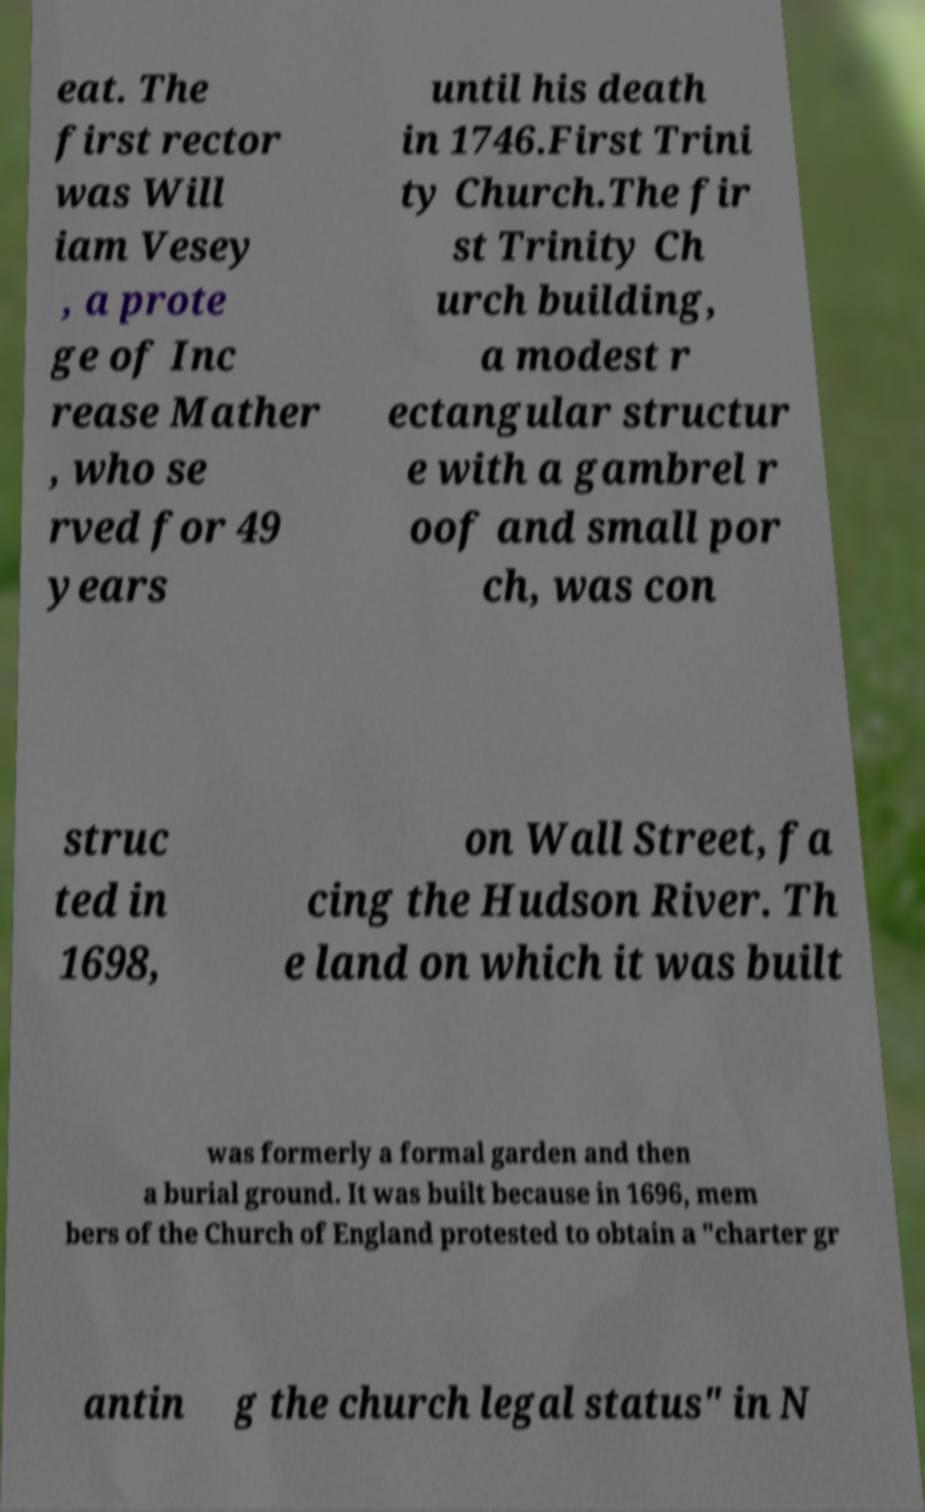What messages or text are displayed in this image? I need them in a readable, typed format. eat. The first rector was Will iam Vesey , a prote ge of Inc rease Mather , who se rved for 49 years until his death in 1746.First Trini ty Church.The fir st Trinity Ch urch building, a modest r ectangular structur e with a gambrel r oof and small por ch, was con struc ted in 1698, on Wall Street, fa cing the Hudson River. Th e land on which it was built was formerly a formal garden and then a burial ground. It was built because in 1696, mem bers of the Church of England protested to obtain a "charter gr antin g the church legal status" in N 